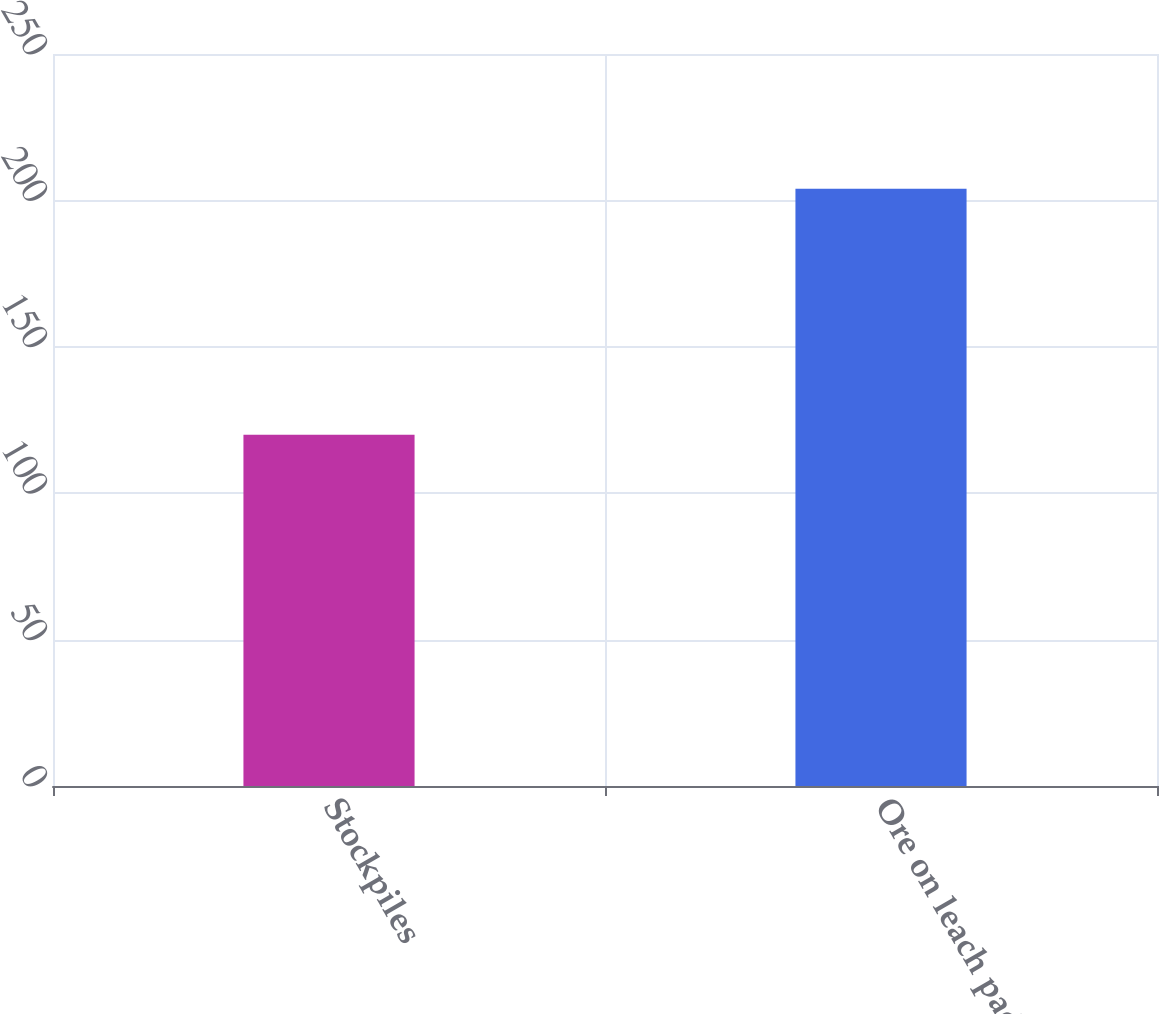Convert chart to OTSL. <chart><loc_0><loc_0><loc_500><loc_500><bar_chart><fcel>Stockpiles<fcel>Ore on leach pads<nl><fcel>120<fcel>204<nl></chart> 